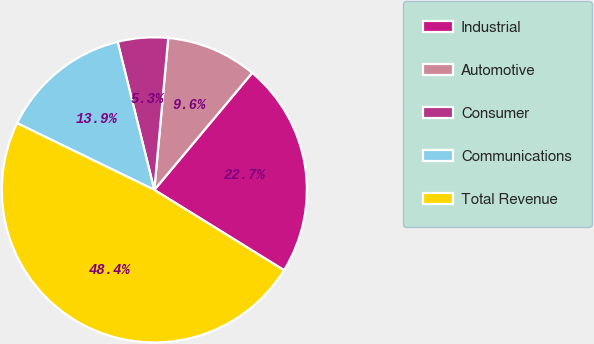Convert chart. <chart><loc_0><loc_0><loc_500><loc_500><pie_chart><fcel>Industrial<fcel>Automotive<fcel>Consumer<fcel>Communications<fcel>Total Revenue<nl><fcel>22.74%<fcel>9.63%<fcel>5.32%<fcel>13.93%<fcel>48.38%<nl></chart> 